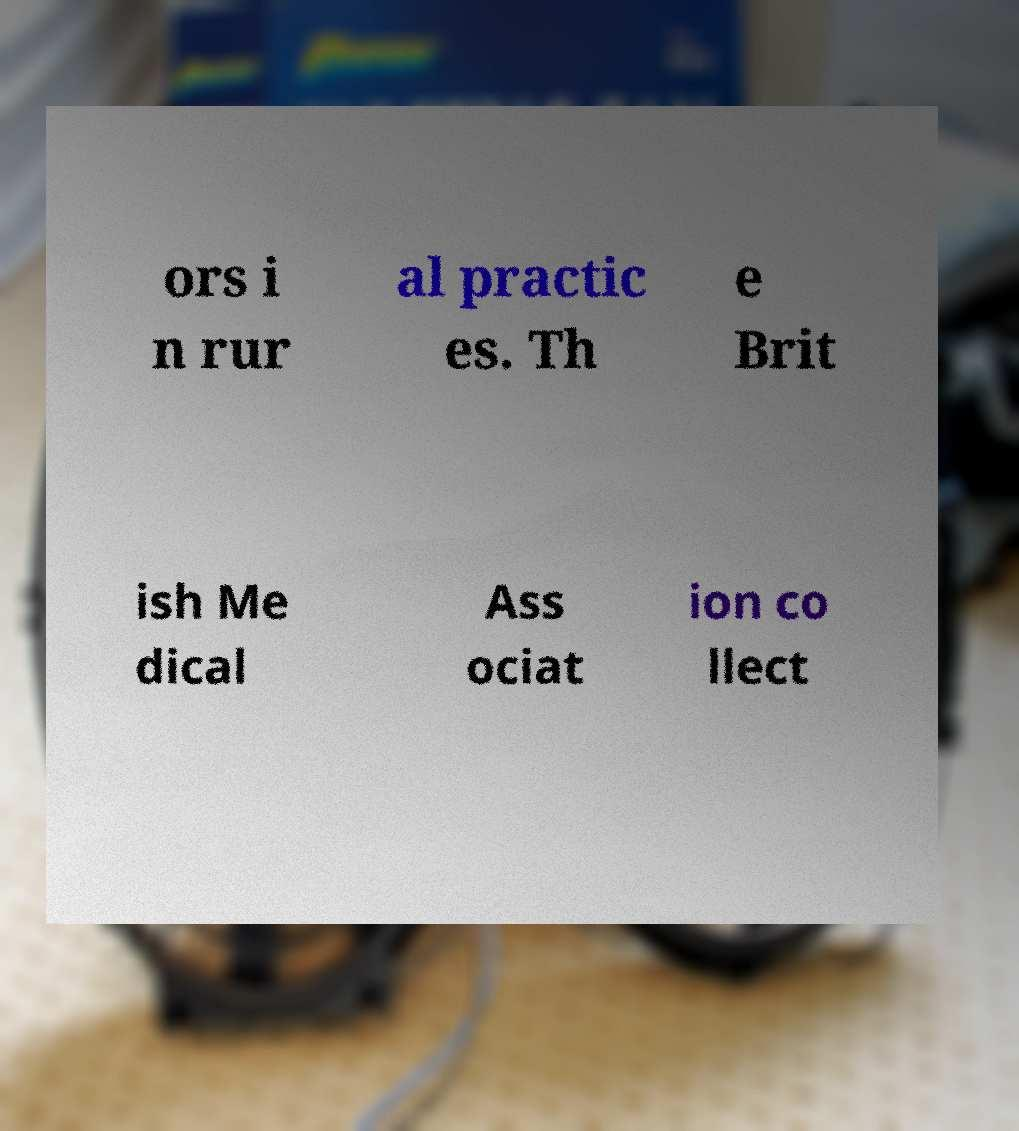There's text embedded in this image that I need extracted. Can you transcribe it verbatim? ors i n rur al practic es. Th e Brit ish Me dical Ass ociat ion co llect 